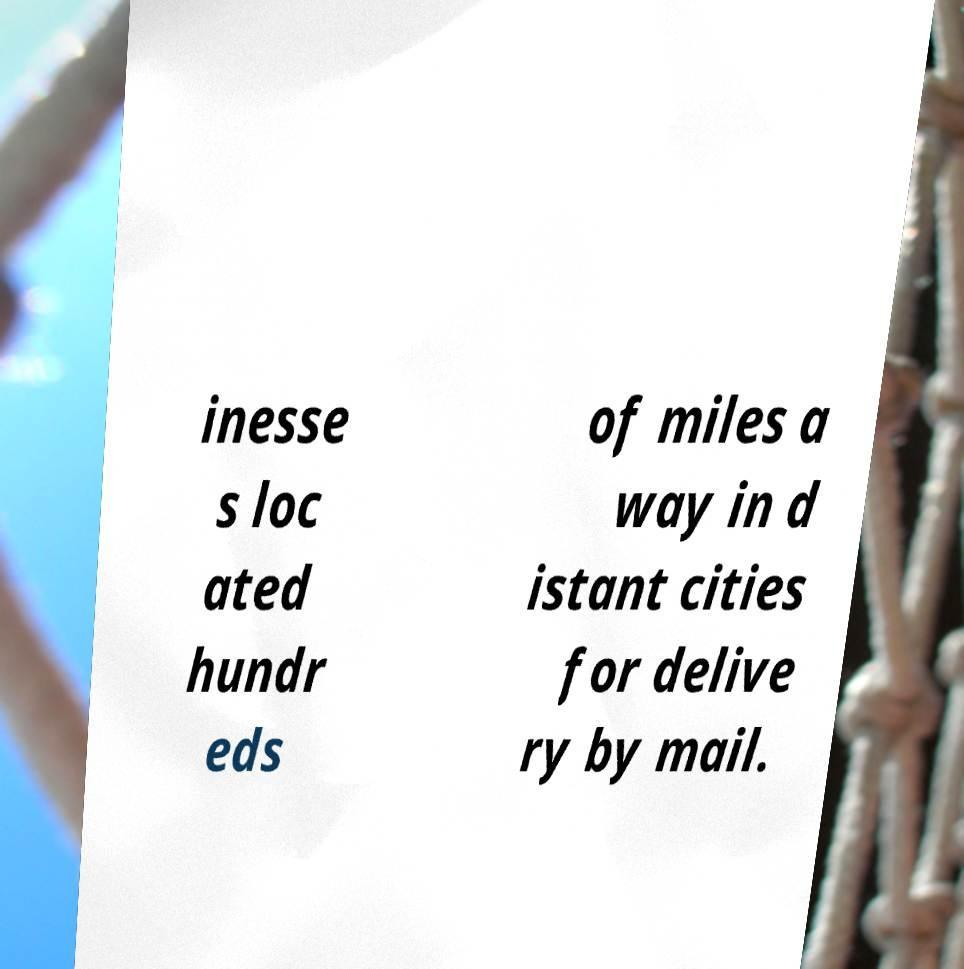Could you assist in decoding the text presented in this image and type it out clearly? inesse s loc ated hundr eds of miles a way in d istant cities for delive ry by mail. 